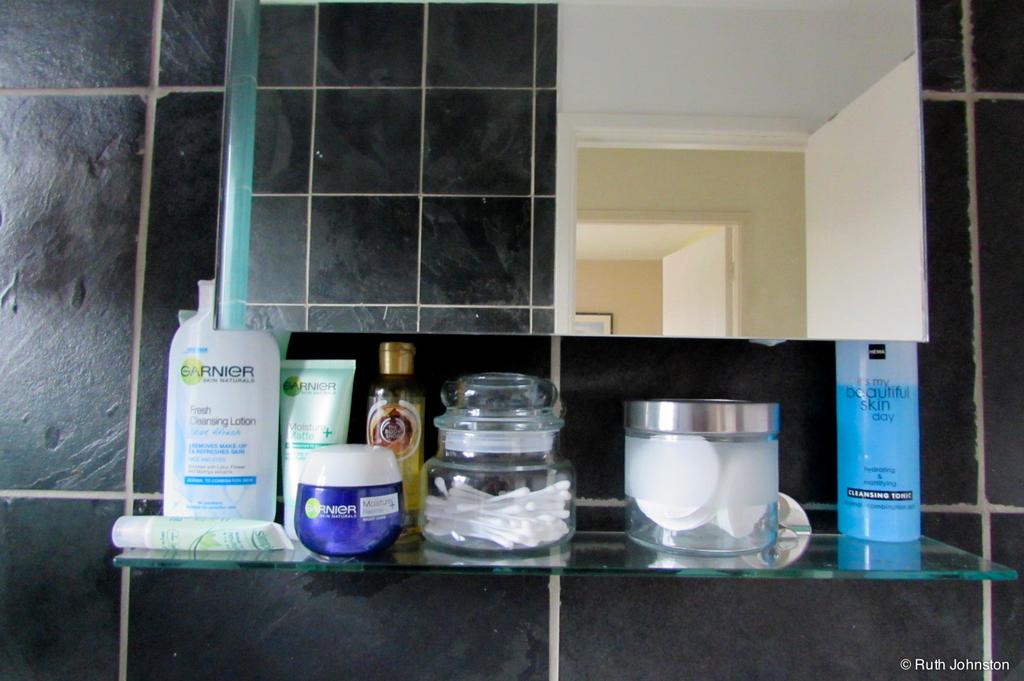What brand is featured?
Offer a terse response. Garnier. 